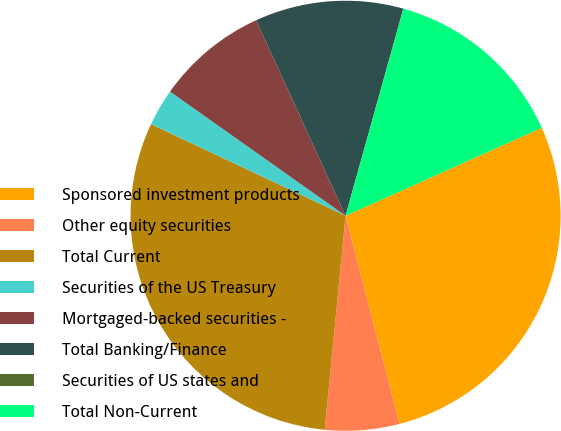<chart> <loc_0><loc_0><loc_500><loc_500><pie_chart><fcel>Sponsored investment products<fcel>Other equity securities<fcel>Total Current<fcel>Securities of the US Treasury<fcel>Mortgaged-backed securities -<fcel>Total Banking/Finance<fcel>Securities of US states and<fcel>Total Non-Current<nl><fcel>27.67%<fcel>5.58%<fcel>30.46%<fcel>2.79%<fcel>8.37%<fcel>11.16%<fcel>0.01%<fcel>13.95%<nl></chart> 